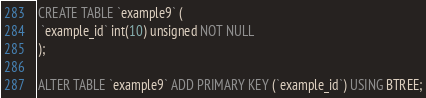<code> <loc_0><loc_0><loc_500><loc_500><_SQL_>CREATE TABLE `example9` (
 `example_id` int(10) unsigned NOT NULL
);

ALTER TABLE `example9` ADD PRIMARY KEY (`example_id`) USING BTREE;</code> 